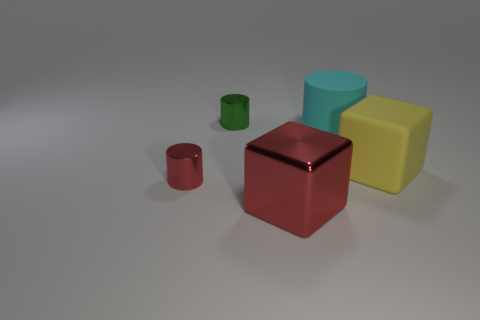Subtract all small metallic cylinders. How many cylinders are left? 1 Add 3 small cyan rubber objects. How many objects exist? 8 Subtract 1 cylinders. How many cylinders are left? 2 Subtract all red cylinders. How many cylinders are left? 2 Subtract all blocks. How many objects are left? 3 Subtract all red cubes. Subtract all blue cylinders. How many cubes are left? 1 Subtract all tiny purple cylinders. Subtract all big red things. How many objects are left? 4 Add 4 red shiny objects. How many red shiny objects are left? 6 Add 1 big metal things. How many big metal things exist? 2 Subtract 0 cyan balls. How many objects are left? 5 